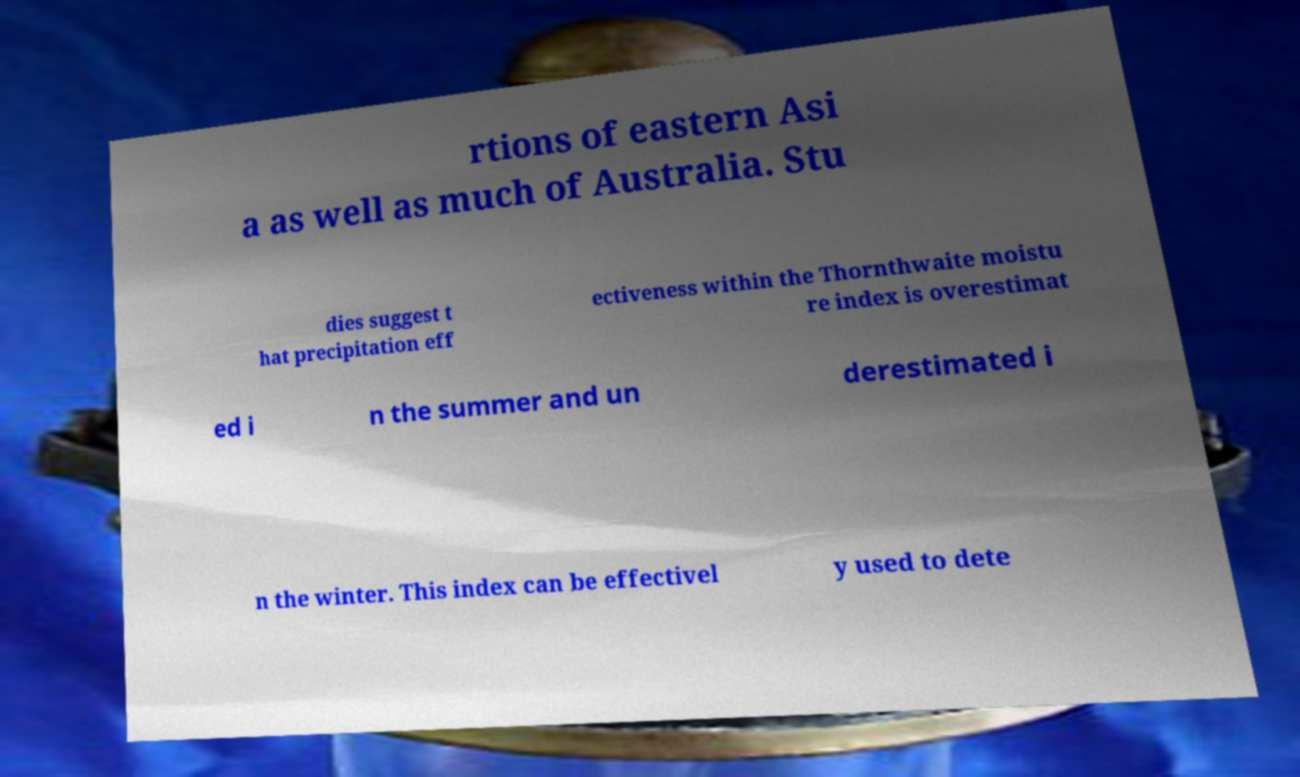Can you read and provide the text displayed in the image?This photo seems to have some interesting text. Can you extract and type it out for me? rtions of eastern Asi a as well as much of Australia. Stu dies suggest t hat precipitation eff ectiveness within the Thornthwaite moistu re index is overestimat ed i n the summer and un derestimated i n the winter. This index can be effectivel y used to dete 